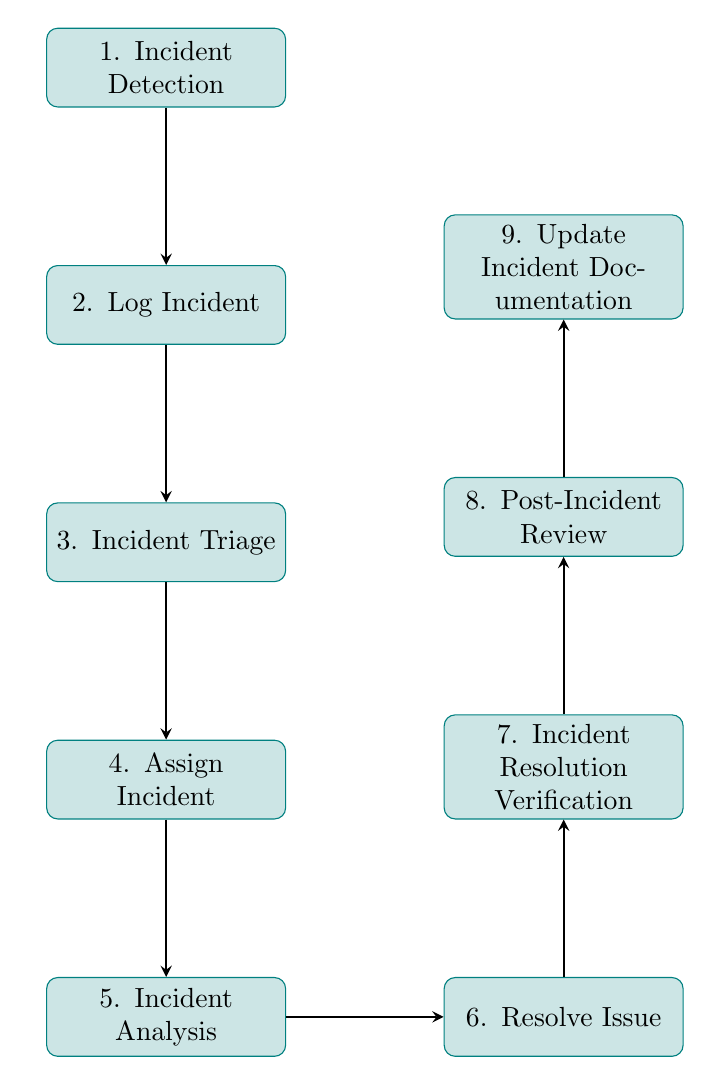What is the first step in the incident response workflow? The first step, as indicated in the diagram, is the "Incident Detection" node, where a system or user detects an anomaly or issue.
Answer: Incident Detection How many nodes are there in the diagram? By counting the labeled nodes from 1 to 9 in the diagram, we find that there are nine nodes in total representing different steps in the incident response workflow.
Answer: 9 What is the immediate next step after "Log Incident"? From the diagram, after "Log Incident," the workflow moves to "Incident Triage," which is the next node in the sequence.
Answer: Incident Triage Which node comes before "Post-Incident Review"? To find the node that precedes "Post-Incident Review," we look at the flow of the diagram. The node that comes directly before it is "Incident Resolution Verification."
Answer: Incident Resolution Verification What is the last step in the incident response workflow? The final step in the workflow, as illustrated in the diagram, is "Update Incident Documentation," which is the last node in the sequence.
Answer: Update Incident Documentation How many edges are present in the diagram? The edges represent the connections between nodes, and by counting them, we can see that there are eight edges connecting the nine nodes in the incident response workflow.
Answer: 8 What is the purpose of "Incident Analysis"? According to the description in the diagram, "Incident Analysis" focuses on analyzing the incident to identify its root cause, which is critical for resolving the issue effectively.
Answer: Analyze incident to identify root cause Which node has the responsibility of assigning an incident? The node responsible for assigning the incident, based on the diagram's flow, is "Assign Incident." This step involves designating the incident to the appropriate response team.
Answer: Assign Incident 